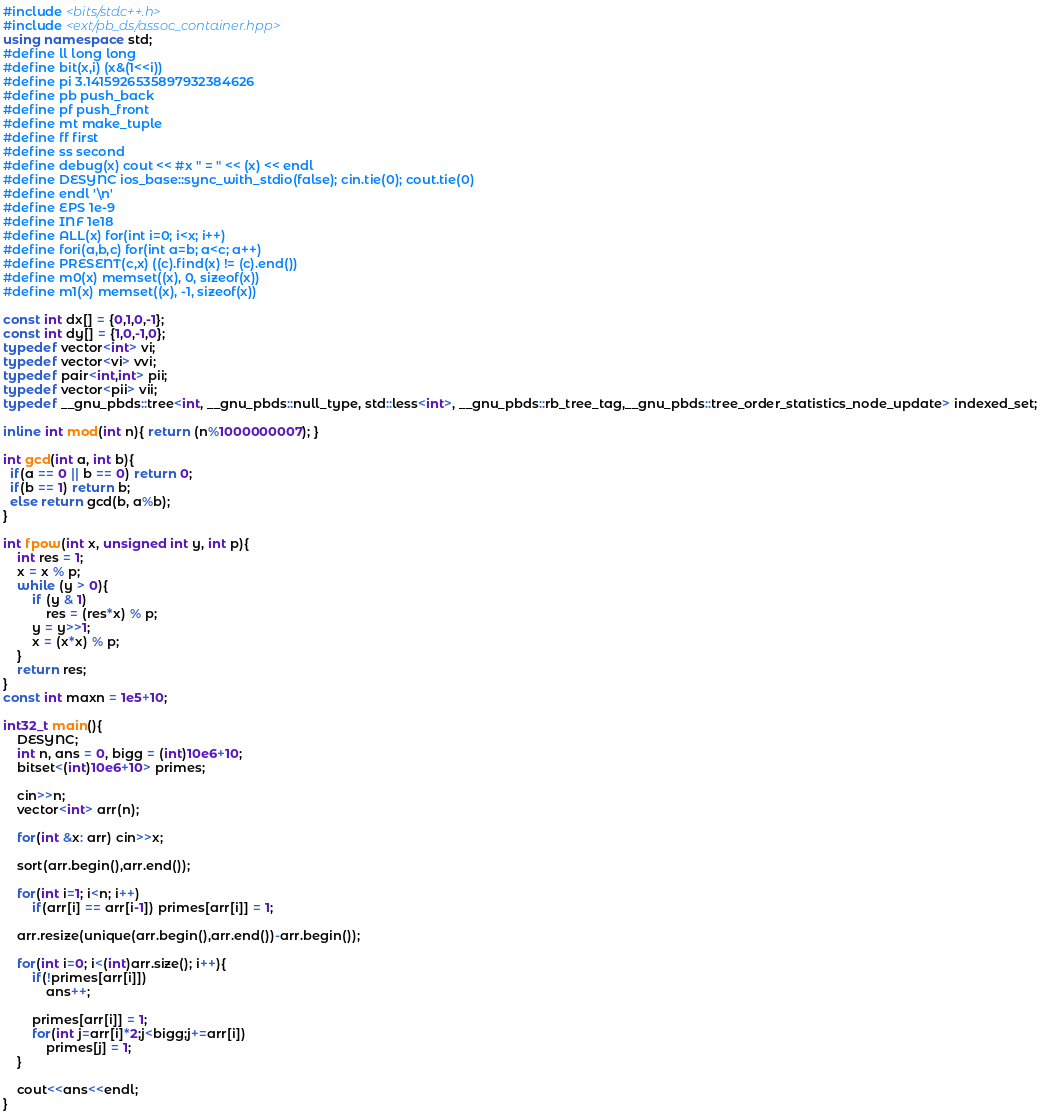<code> <loc_0><loc_0><loc_500><loc_500><_C++_>#include <bits/stdc++.h>
#include <ext/pb_ds/assoc_container.hpp>
using namespace std;
#define ll long long
#define bit(x,i) (x&(1<<i))
#define pi 3.1415926535897932384626
#define pb push_back
#define pf push_front
#define mt make_tuple
#define ff first
#define ss second
#define debug(x) cout << #x " = " << (x) << endl
#define DESYNC ios_base::sync_with_stdio(false); cin.tie(0); cout.tie(0)
#define endl '\n'
#define EPS 1e-9
#define INF 1e18
#define ALL(x) for(int i=0; i<x; i++)
#define fori(a,b,c) for(int a=b; a<c; a++)
#define PRESENT(c,x) ((c).find(x) != (c).end())
#define m0(x) memset((x), 0, sizeof(x))
#define m1(x) memset((x), -1, sizeof(x))

const int dx[] = {0,1,0,-1};
const int dy[] = {1,0,-1,0};
typedef vector<int> vi; 
typedef vector<vi> vvi; 
typedef pair<int,int> pii;
typedef vector<pii> vii;
typedef __gnu_pbds::tree<int, __gnu_pbds::null_type, std::less<int>, __gnu_pbds::rb_tree_tag,__gnu_pbds::tree_order_statistics_node_update> indexed_set;

inline int mod(int n){ return (n%1000000007); }

int gcd(int a, int b){
  if(a == 0 || b == 0) return 0;
  if(b == 1) return b;
  else return gcd(b, a%b);
}

int fpow(int x, unsigned int y, int p){ 
    int res = 1;
    x = x % p;
    while (y > 0){
        if (y & 1) 
            res = (res*x) % p; 
        y = y>>1;
        x = (x*x) % p;   
    } 
    return res; 
} 
const int maxn = 1e5+10;

int32_t main(){
	DESYNC;
    int n, ans = 0, bigg = (int)10e6+10;
    bitset<(int)10e6+10> primes;

    cin>>n;
    vector<int> arr(n);

    for(int &x: arr) cin>>x;

    sort(arr.begin(),arr.end());

    for(int i=1; i<n; i++)
        if(arr[i] == arr[i-1]) primes[arr[i]] = 1;

    arr.resize(unique(arr.begin(),arr.end())-arr.begin());

    for(int i=0; i<(int)arr.size(); i++){
        if(!primes[arr[i]])
            ans++;

        primes[arr[i]] = 1;
        for(int j=arr[i]*2;j<bigg;j+=arr[i])
            primes[j] = 1;
    }

    cout<<ans<<endl;
}</code> 